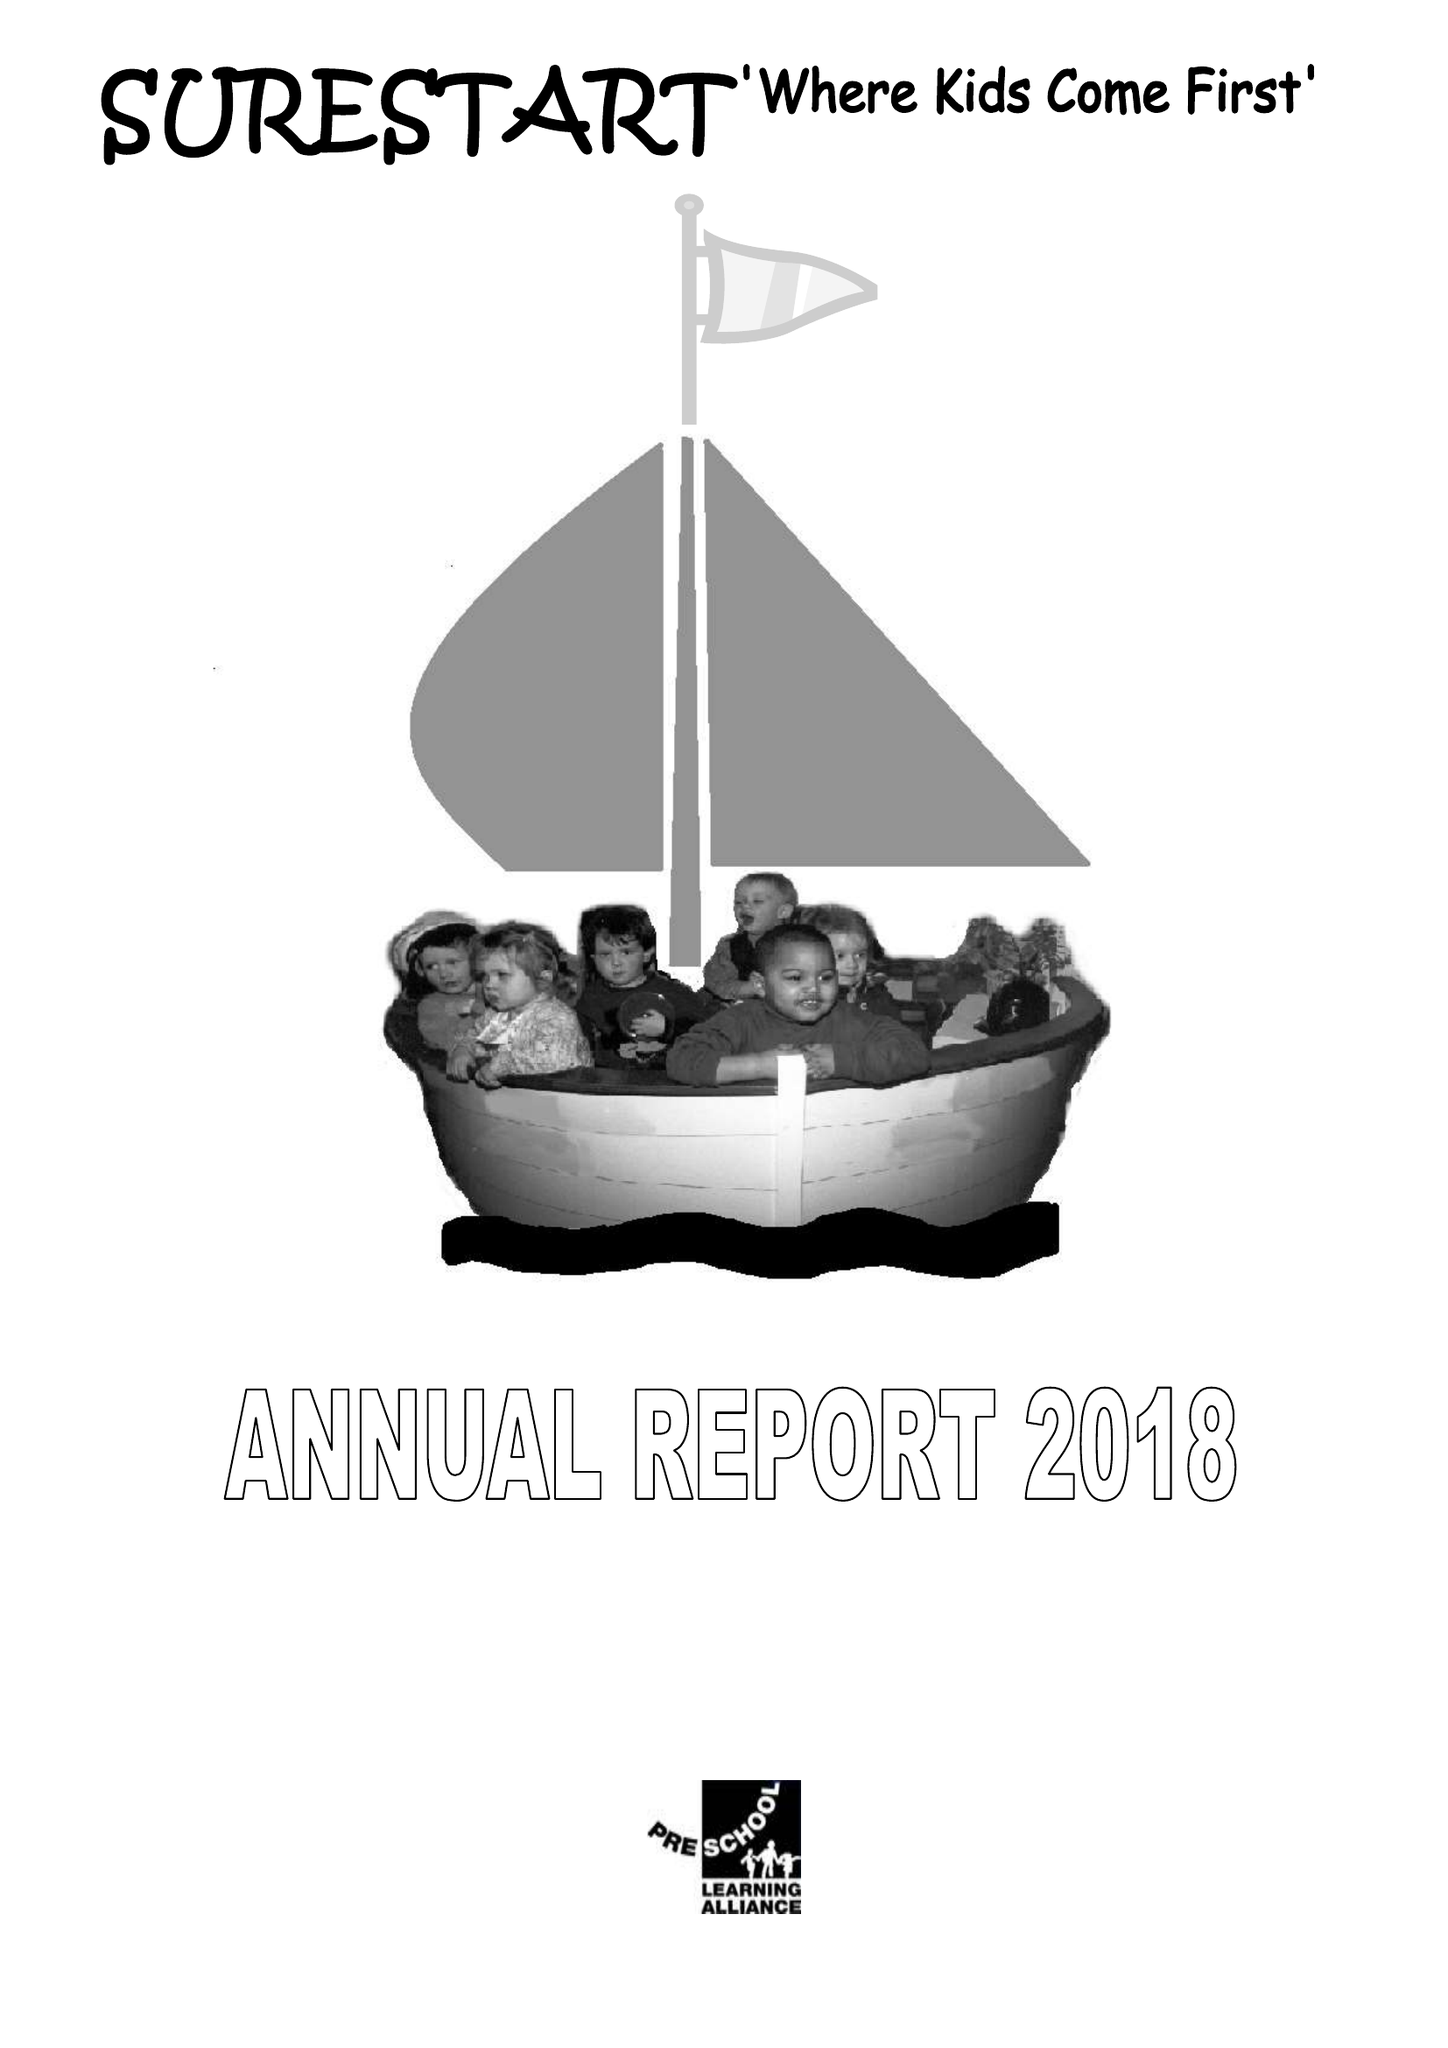What is the value for the spending_annually_in_british_pounds?
Answer the question using a single word or phrase. 243832.00 